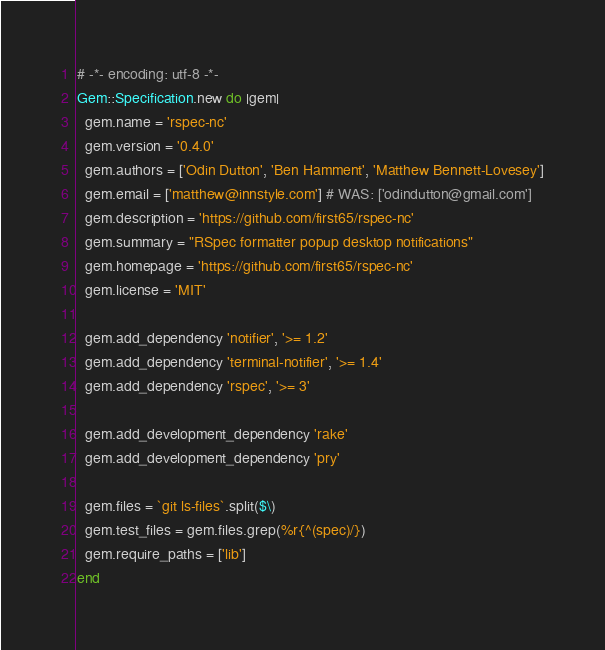Convert code to text. <code><loc_0><loc_0><loc_500><loc_500><_Ruby_># -*- encoding: utf-8 -*-
Gem::Specification.new do |gem|
  gem.name = 'rspec-nc'
  gem.version = '0.4.0'
  gem.authors = ['Odin Dutton', 'Ben Hamment', 'Matthew Bennett-Lovesey']
  gem.email = ['matthew@innstyle.com'] # WAS: ['odindutton@gmail.com']
  gem.description = 'https://github.com/first65/rspec-nc'
  gem.summary = "RSpec formatter popup desktop notifications"
  gem.homepage = 'https://github.com/first65/rspec-nc'
  gem.license = 'MIT'

  gem.add_dependency 'notifier', '>= 1.2'
  gem.add_dependency 'terminal-notifier', '>= 1.4'
  gem.add_dependency 'rspec', '>= 3'

  gem.add_development_dependency 'rake'
  gem.add_development_dependency 'pry'

  gem.files = `git ls-files`.split($\)
  gem.test_files = gem.files.grep(%r{^(spec)/})
  gem.require_paths = ['lib']
end
</code> 